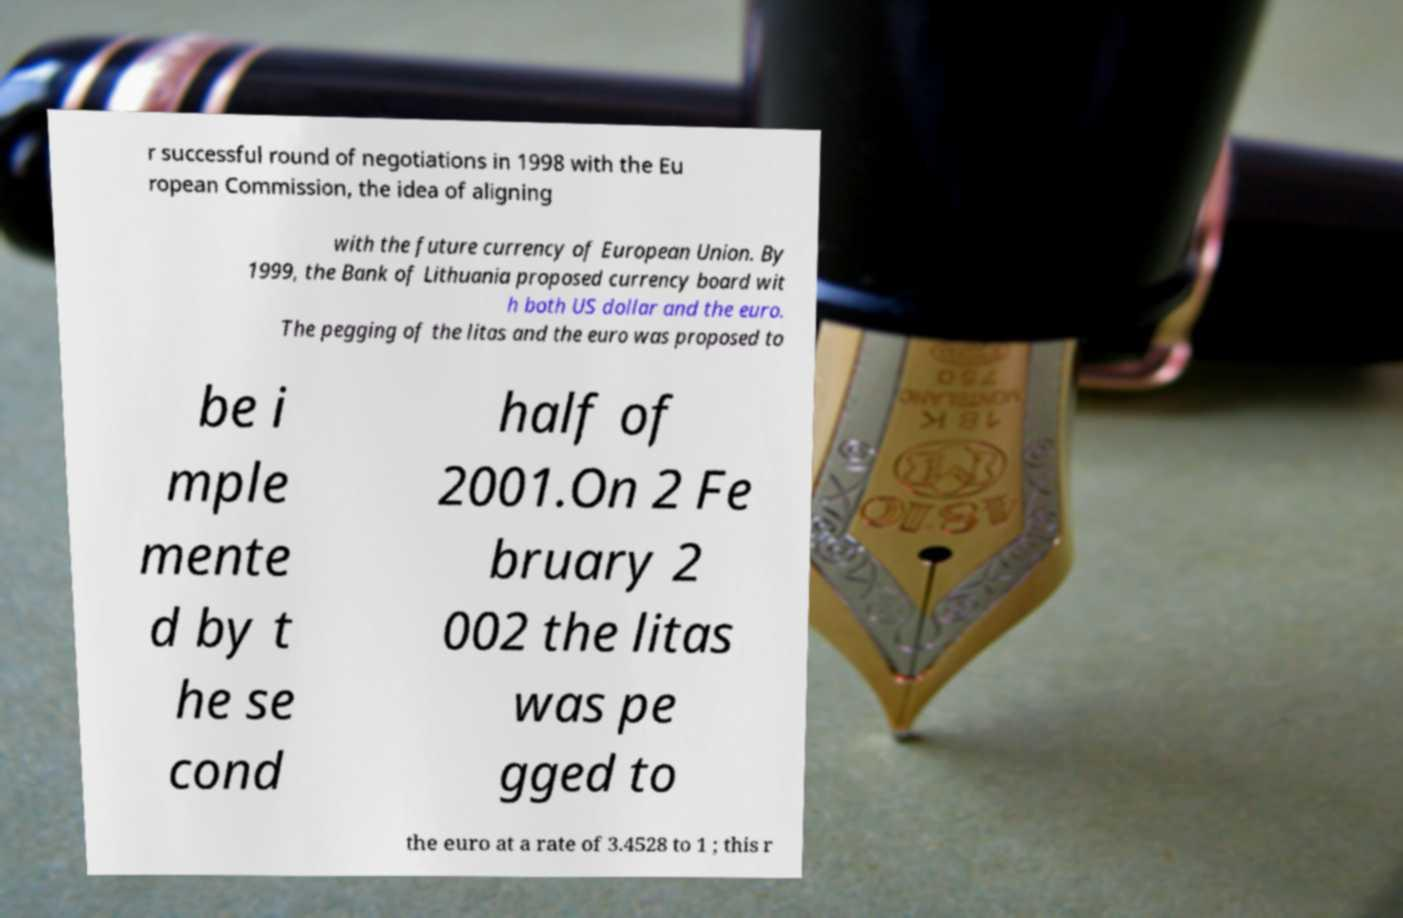Can you read and provide the text displayed in the image?This photo seems to have some interesting text. Can you extract and type it out for me? r successful round of negotiations in 1998 with the Eu ropean Commission, the idea of aligning with the future currency of European Union. By 1999, the Bank of Lithuania proposed currency board wit h both US dollar and the euro. The pegging of the litas and the euro was proposed to be i mple mente d by t he se cond half of 2001.On 2 Fe bruary 2 002 the litas was pe gged to the euro at a rate of 3.4528 to 1 ; this r 